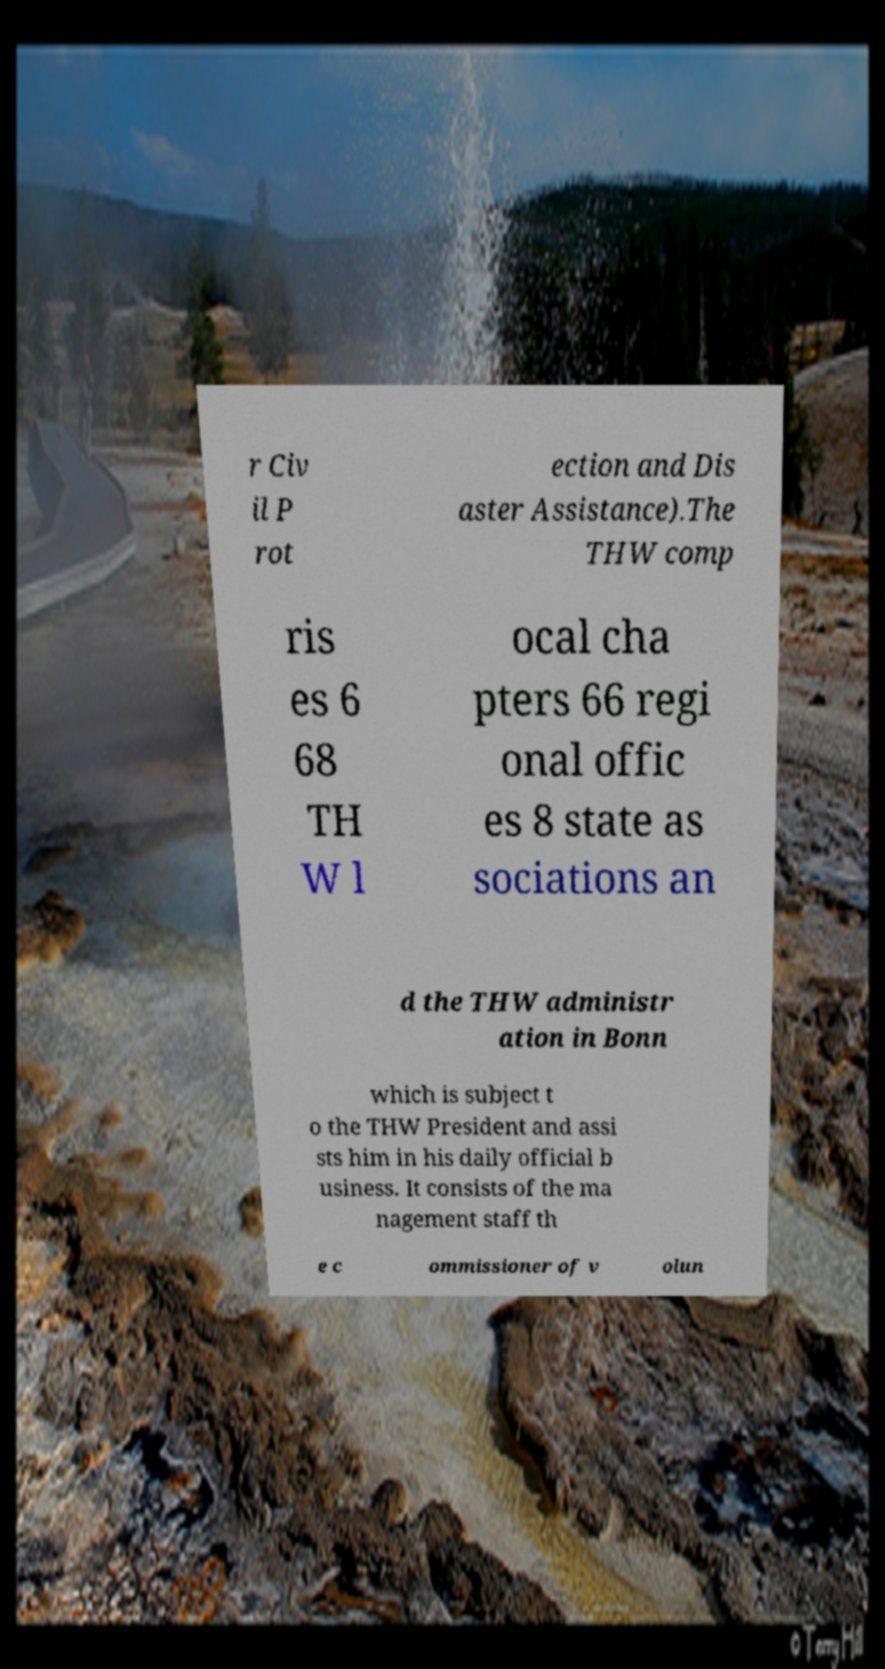Please identify and transcribe the text found in this image. r Civ il P rot ection and Dis aster Assistance).The THW comp ris es 6 68 TH W l ocal cha pters 66 regi onal offic es 8 state as sociations an d the THW administr ation in Bonn which is subject t o the THW President and assi sts him in his daily official b usiness. It consists of the ma nagement staff th e c ommissioner of v olun 